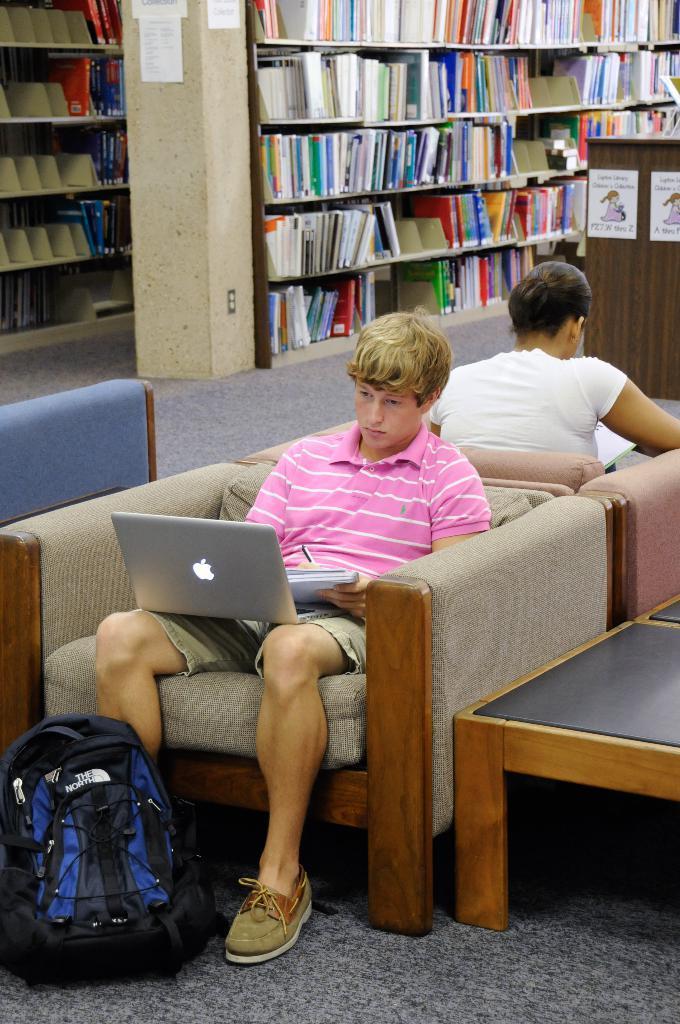How would you summarize this image in a sentence or two? Here we can see two people sitting on chairs and the man in the front is having a laptop in his hand and the person behind him is reading a book and there is a bag in front of the man and besides them there is a table and behind them we can see bookshelves 